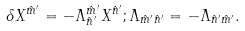Convert formula to latex. <formula><loc_0><loc_0><loc_500><loc_500>\delta X ^ { \hat { m } ^ { \prime } } = - \Lambda _ { \hat { n } ^ { \prime } } ^ { \hat { m } ^ { \prime } } X ^ { \hat { n } ^ { \prime } } ; \Lambda _ { \hat { m } ^ { \prime } \hat { n } ^ { \prime } } = - \Lambda _ { \hat { n } ^ { \prime } \hat { m } ^ { \prime } } .</formula> 